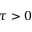<formula> <loc_0><loc_0><loc_500><loc_500>\tau > 0</formula> 